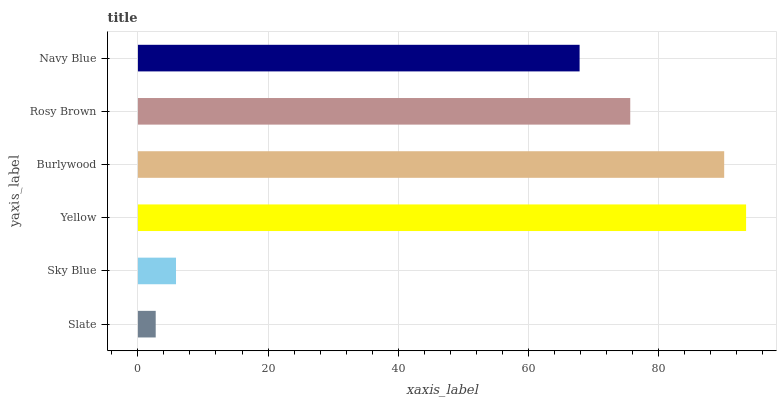Is Slate the minimum?
Answer yes or no. Yes. Is Yellow the maximum?
Answer yes or no. Yes. Is Sky Blue the minimum?
Answer yes or no. No. Is Sky Blue the maximum?
Answer yes or no. No. Is Sky Blue greater than Slate?
Answer yes or no. Yes. Is Slate less than Sky Blue?
Answer yes or no. Yes. Is Slate greater than Sky Blue?
Answer yes or no. No. Is Sky Blue less than Slate?
Answer yes or no. No. Is Rosy Brown the high median?
Answer yes or no. Yes. Is Navy Blue the low median?
Answer yes or no. Yes. Is Slate the high median?
Answer yes or no. No. Is Rosy Brown the low median?
Answer yes or no. No. 